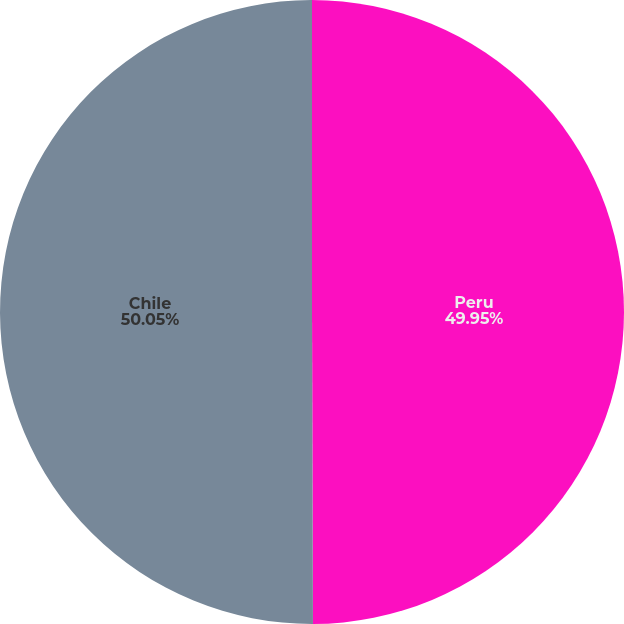Convert chart to OTSL. <chart><loc_0><loc_0><loc_500><loc_500><pie_chart><fcel>Peru<fcel>Chile<nl><fcel>49.95%<fcel>50.05%<nl></chart> 